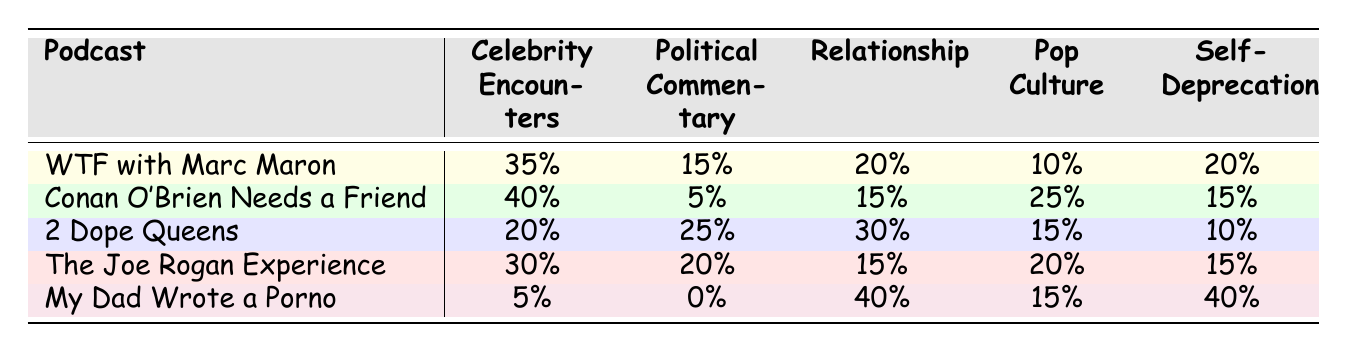What is the highest percentage of joke topics found in "Conan O'Brien Needs a Friend"? The table shows that "Conan O'Brien Needs a Friend" has the highest percentage for "Celebrity Encounters" at 40%.
Answer: 40% Which podcast focuses most on political commentary? "2 Dope Queens" has the highest percentage for political commentary at 25%, which is higher than all other podcasts.
Answer: 2 Dope Queens What is the average percentage of self-deprecation across all podcasts? Adding the self-deprecation values: (20 + 15 + 10 + 15 + 40) = 100. There are 5 podcasts, so the average is 100/5 = 20.
Answer: 20 Is "My Dad Wrote a Porno" the only podcast with 0% political commentary? Referring to the table, "My Dad Wrote a Porno" has a 0% for political commentary, and no other podcast has this value.
Answer: Yes What is the percentage difference in relationships between "My Dad Wrote a Porno" and "2 Dope Queens"? "My Dad Wrote a Porno" has 40% in relationships, while "2 Dope Queens" has 30%. The difference is 40 - 30 = 10%.
Answer: 10% Which podcast has the lowest percentage of pop culture jokes? The analysis shows that "My Dad Wrote a Porno" and "WTF with Marc Maron" both have 15% for pop culture, which is the lowest value recorded.
Answer: My Dad Wrote a Porno and WTF with Marc Maron How many percentage points more does "Celebrity Encounters" have compared to "Self-Deprecation" in "WTF with Marc Maron"? In "WTF with Marc Maron," "Celebrity Encounters" is 35% and "Self-Deprecation" is 20%. The difference is 35 - 20 = 15 percentage points.
Answer: 15 What is the total percentage of comedy topics concerning relationships across all the podcasts? Summing the relationships percentages gives: (20 + 15 + 30 + 15 + 40) = 120%.
Answer: 120% Which podcast has a higher focus on "Self-Deprecation", "2 Dope Queens" or "The Joe Rogan Experience"? Comparing the values, "2 Dope Queens" has 10% while "The Joe Rogan Experience" has 15%, making the latter higher.
Answer: The Joe Rogan Experience How frequently did "Pop Culture" themes appear in the podcast "WTF with Marc Maron"? The table indicates that "WTF with Marc Maron" had 10% for pop culture themes.
Answer: 10% What theme is most prominent in "My Dad Wrote a Porno"? The data shows that "Relationships" and "Self-Deprecation" both have the highest value at 40%.
Answer: Relationships and Self-Deprecation 